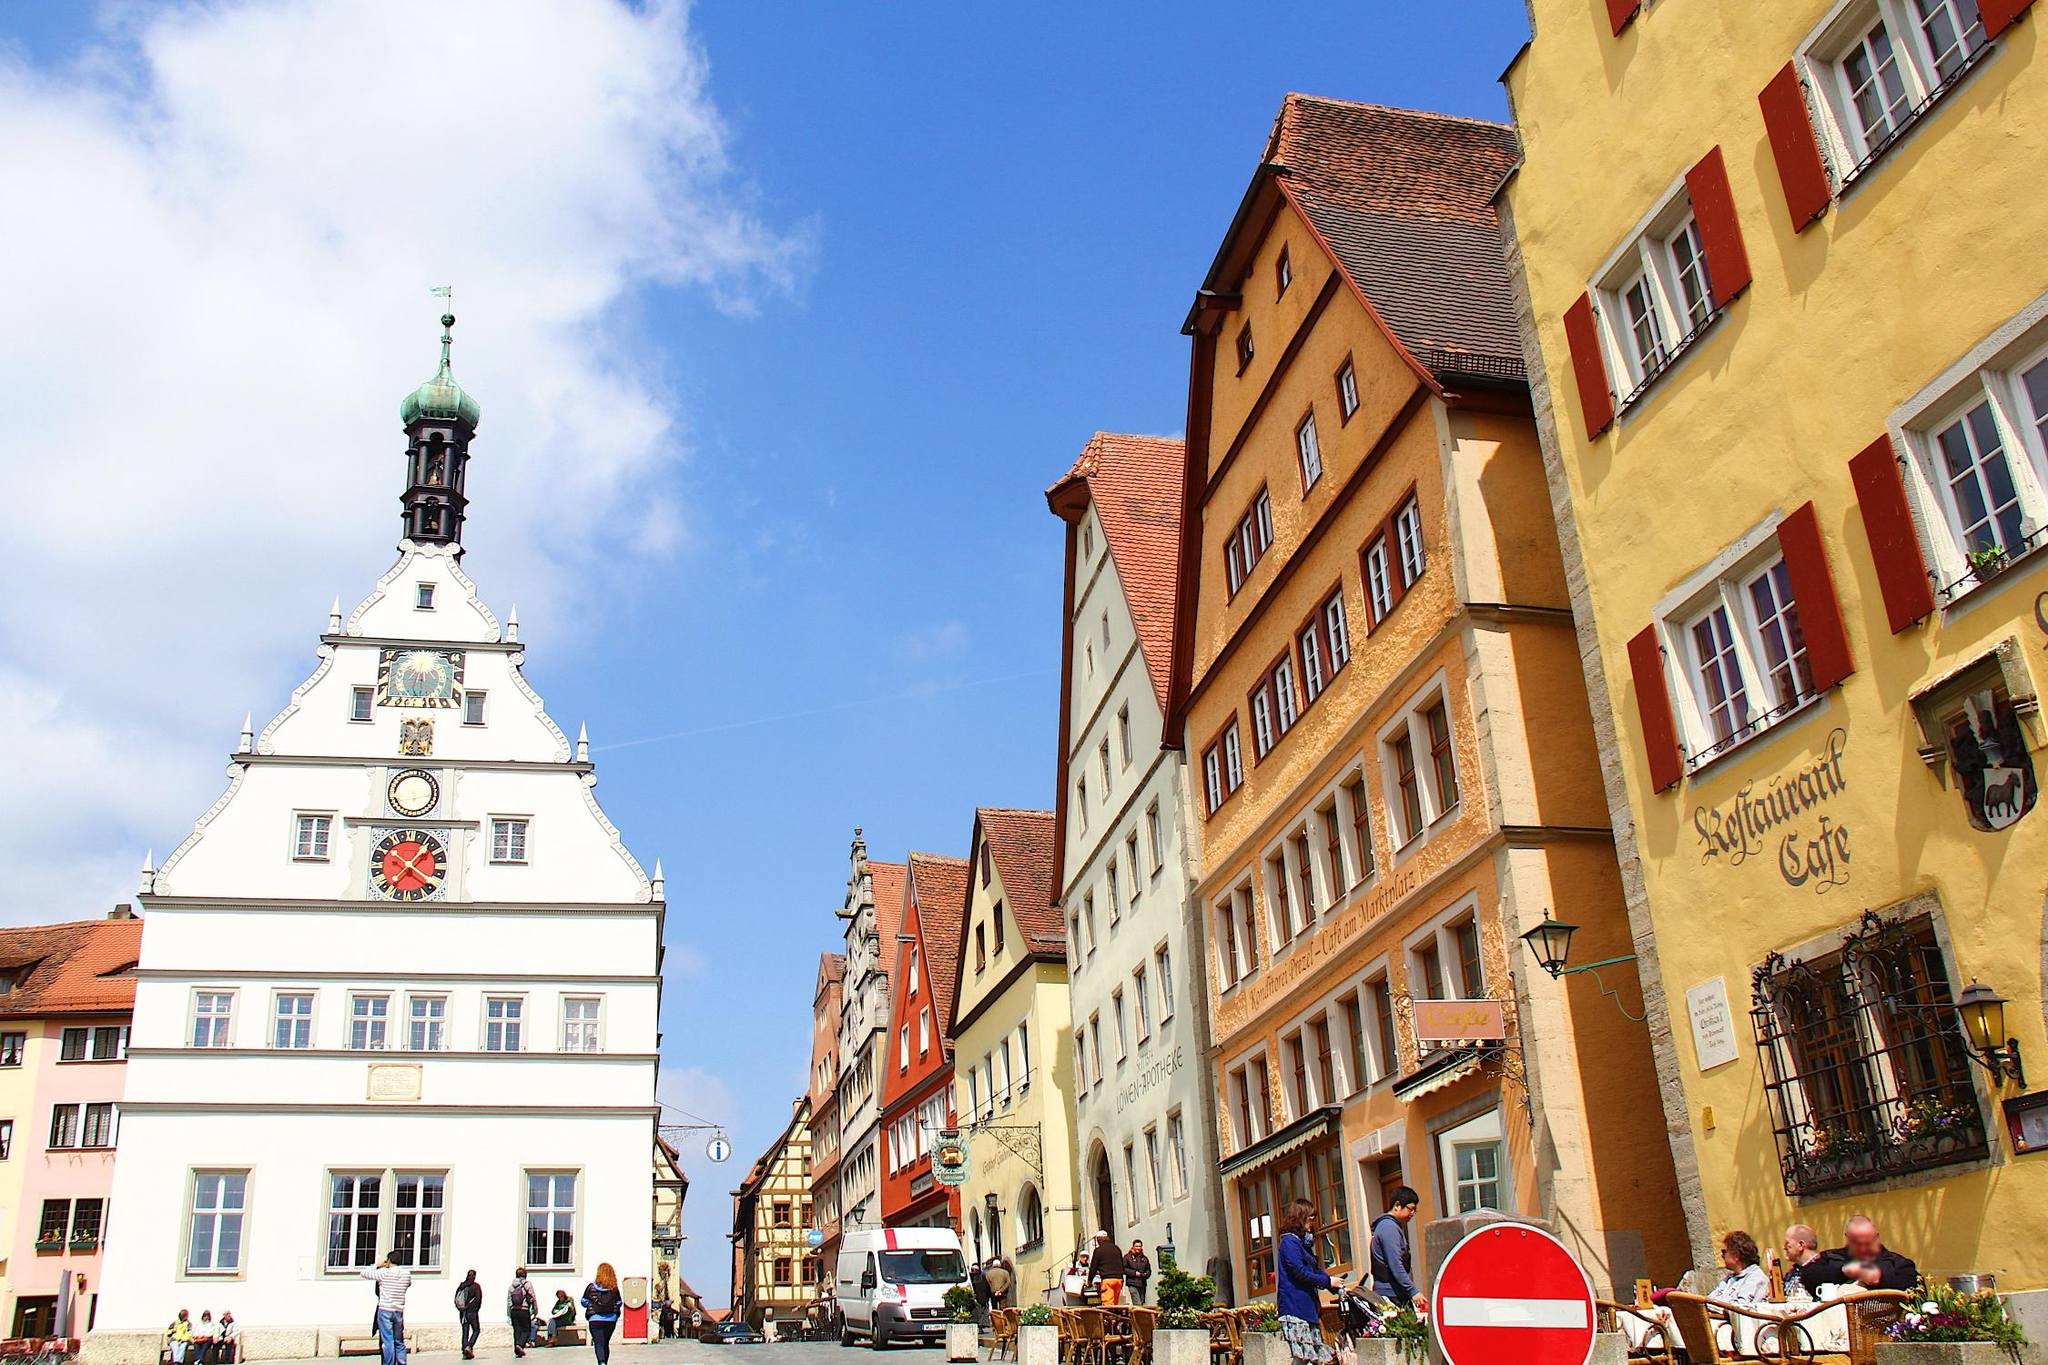Can you tell me more about the architecture seen in this image? The buildings feature typical Franconian architecture, prominently displaying timber framing and truss constructions, common in medieval German towns. The colorful facades are likely restored to maintain their historical appearance, and the detail above the cafe shows a traditional German oriel window, enhancing the building's charm and providing a great vantage point for views of the bustling street below. 